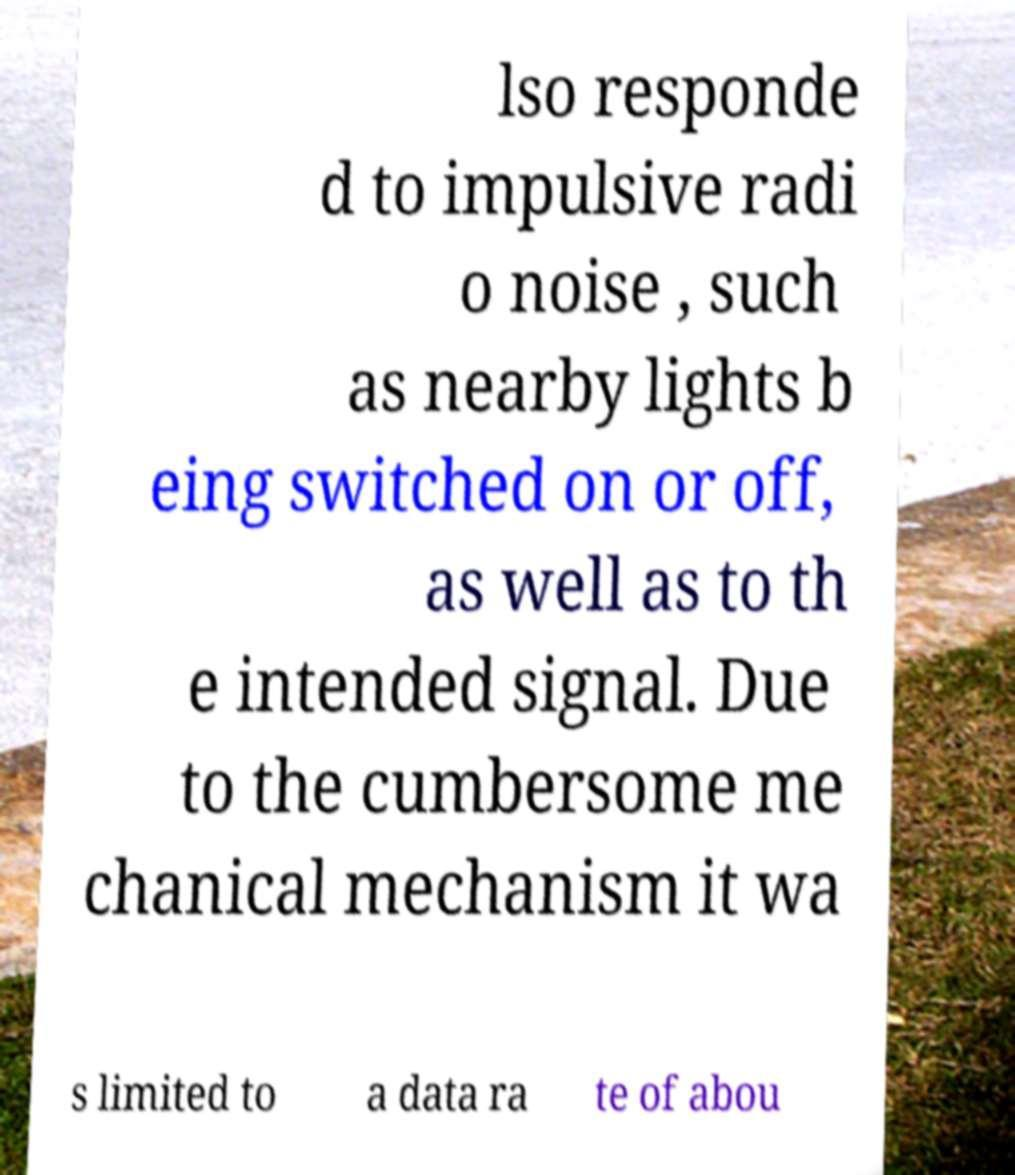What messages or text are displayed in this image? I need them in a readable, typed format. lso responde d to impulsive radi o noise , such as nearby lights b eing switched on or off, as well as to th e intended signal. Due to the cumbersome me chanical mechanism it wa s limited to a data ra te of abou 